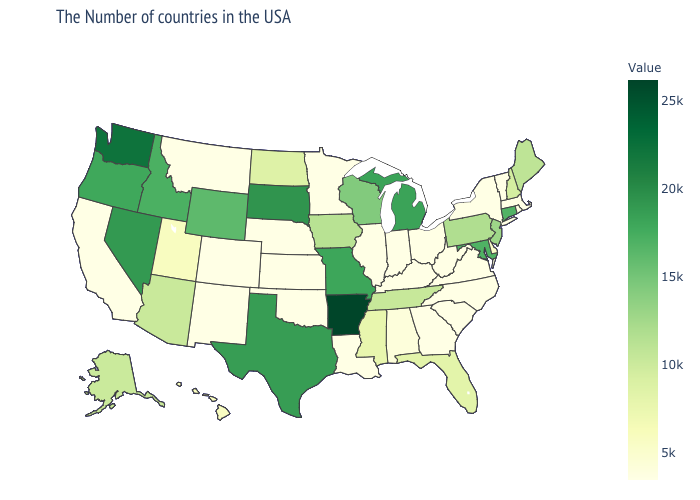Does Montana have the lowest value in the USA?
Keep it brief. Yes. Does Wisconsin have a lower value than Washington?
Answer briefly. Yes. Does Rhode Island have the lowest value in the USA?
Keep it brief. No. Does Arkansas have the highest value in the USA?
Write a very short answer. Yes. Does Connecticut have the highest value in the Northeast?
Quick response, please. Yes. Is the legend a continuous bar?
Short answer required. Yes. 